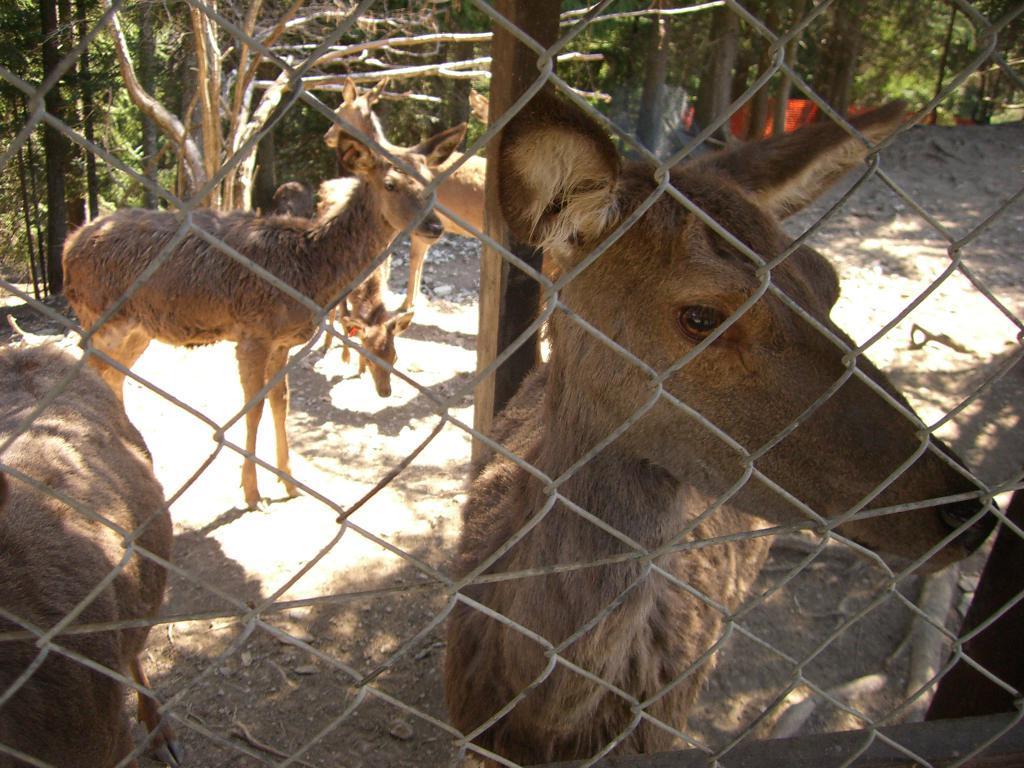Describe this image in one or two sentences. In the given image i can see a animals in the cage and behind them i can see a trunks and trees. 